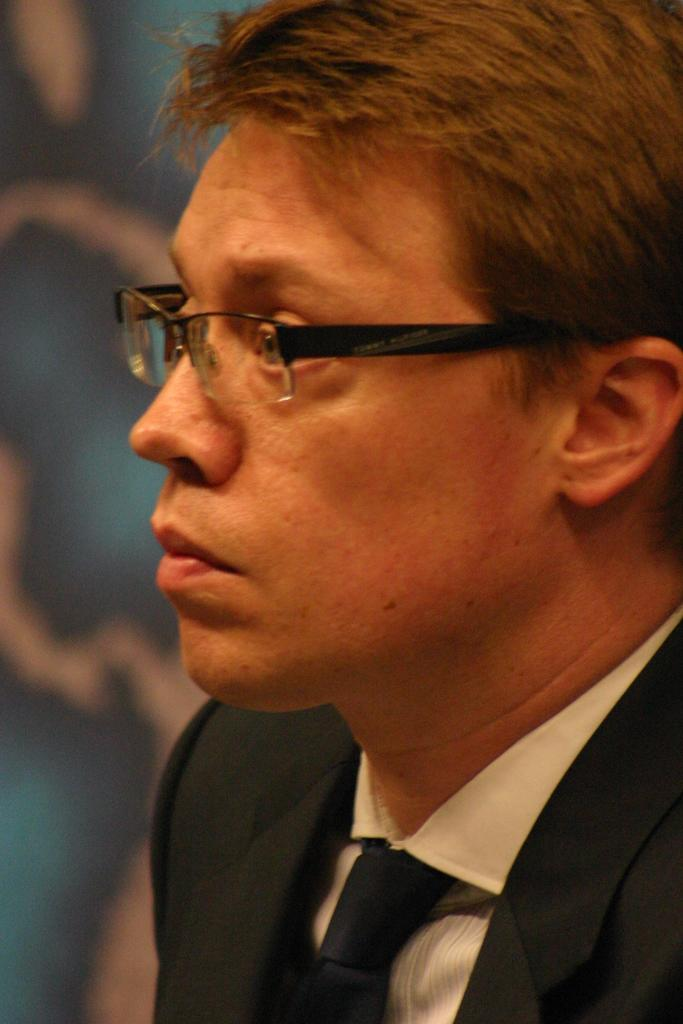Who or what is present in the image? There is a person in the image. What is the person wearing? The person is wearing a black suit and a tie. What type of liquid is being poured by the queen in the image? There is no queen or liquid present in the image; it features a person wearing a black suit and a tie. 